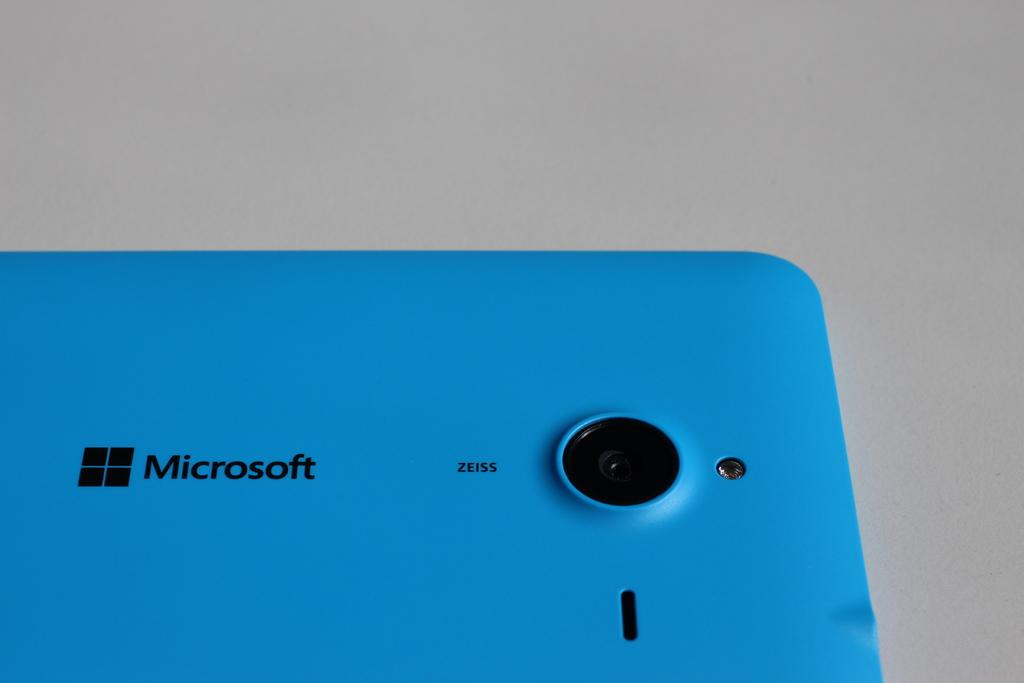<image>
Provide a brief description of the given image. the back of a blue microsoft phone, camera on display 